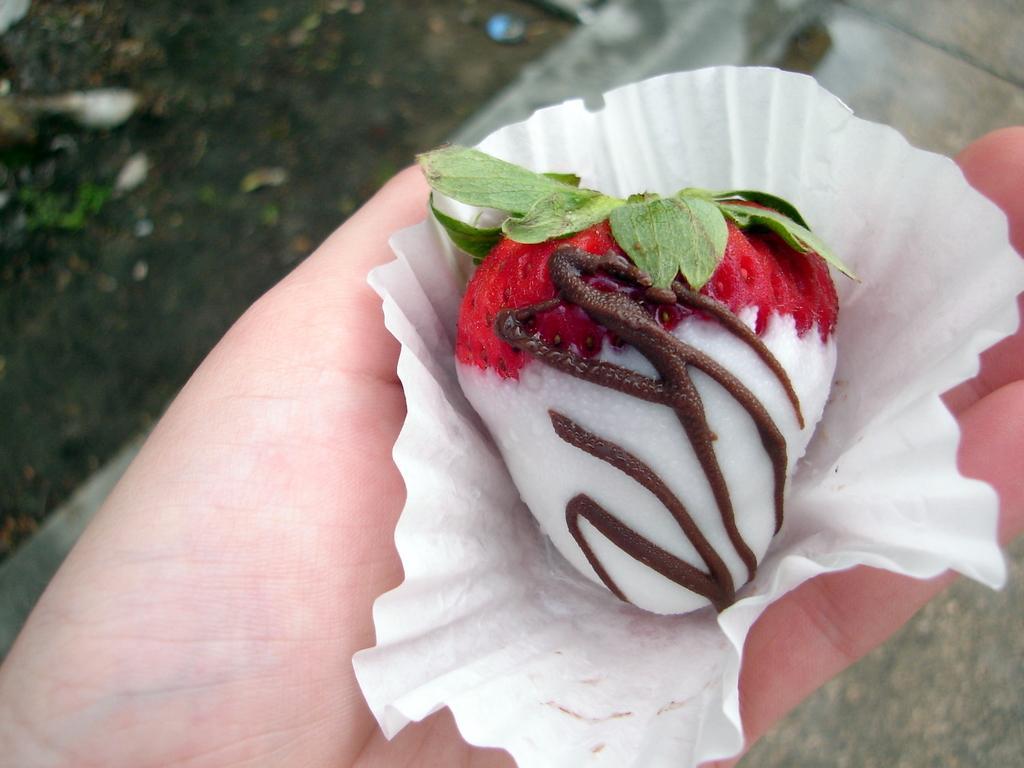Please provide a concise description of this image. In this image there is a strawberry with chocolate on it , on the paper , which is on the person hand , and in the background there is soil. 